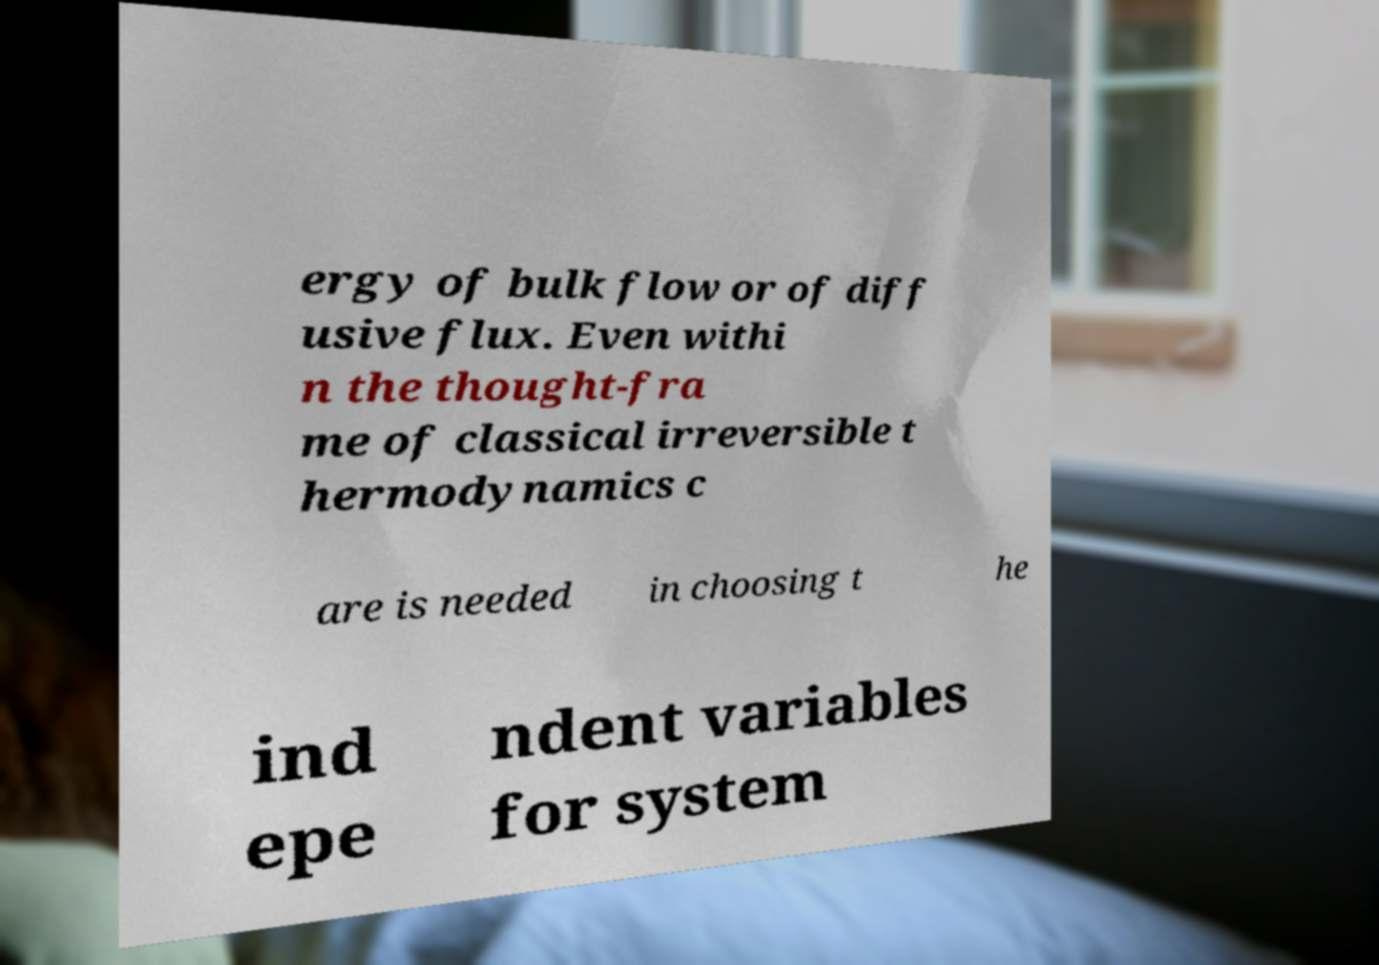Could you extract and type out the text from this image? ergy of bulk flow or of diff usive flux. Even withi n the thought-fra me of classical irreversible t hermodynamics c are is needed in choosing t he ind epe ndent variables for system 